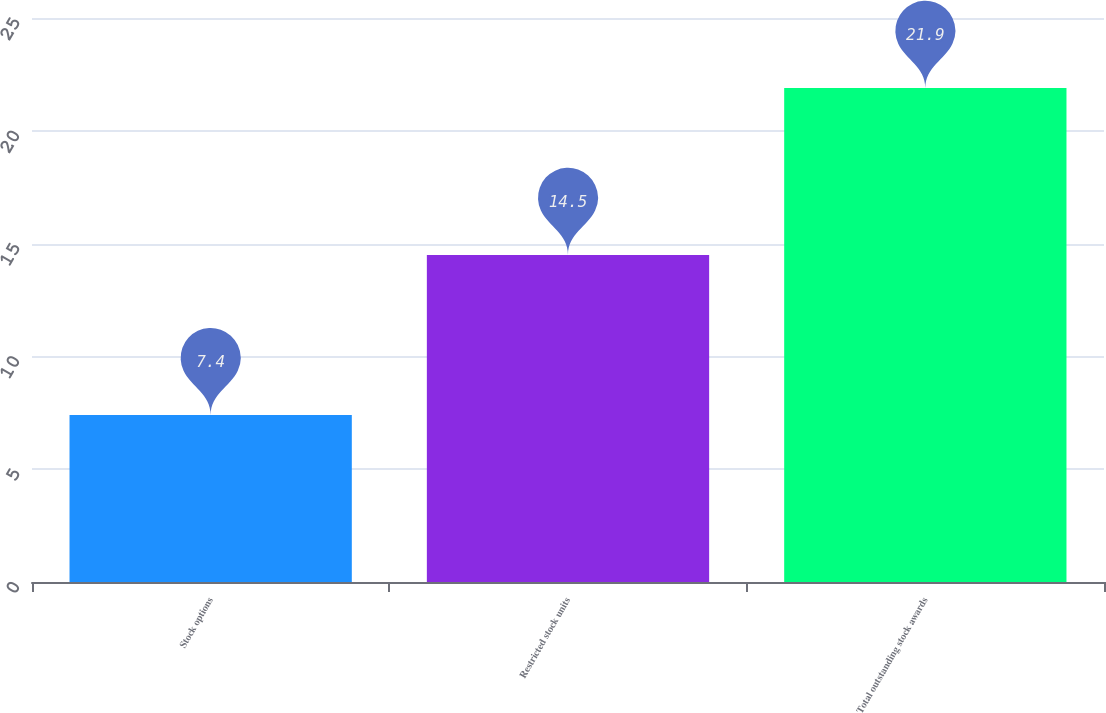Convert chart to OTSL. <chart><loc_0><loc_0><loc_500><loc_500><bar_chart><fcel>Stock options<fcel>Restricted stock units<fcel>Total outstanding stock awards<nl><fcel>7.4<fcel>14.5<fcel>21.9<nl></chart> 